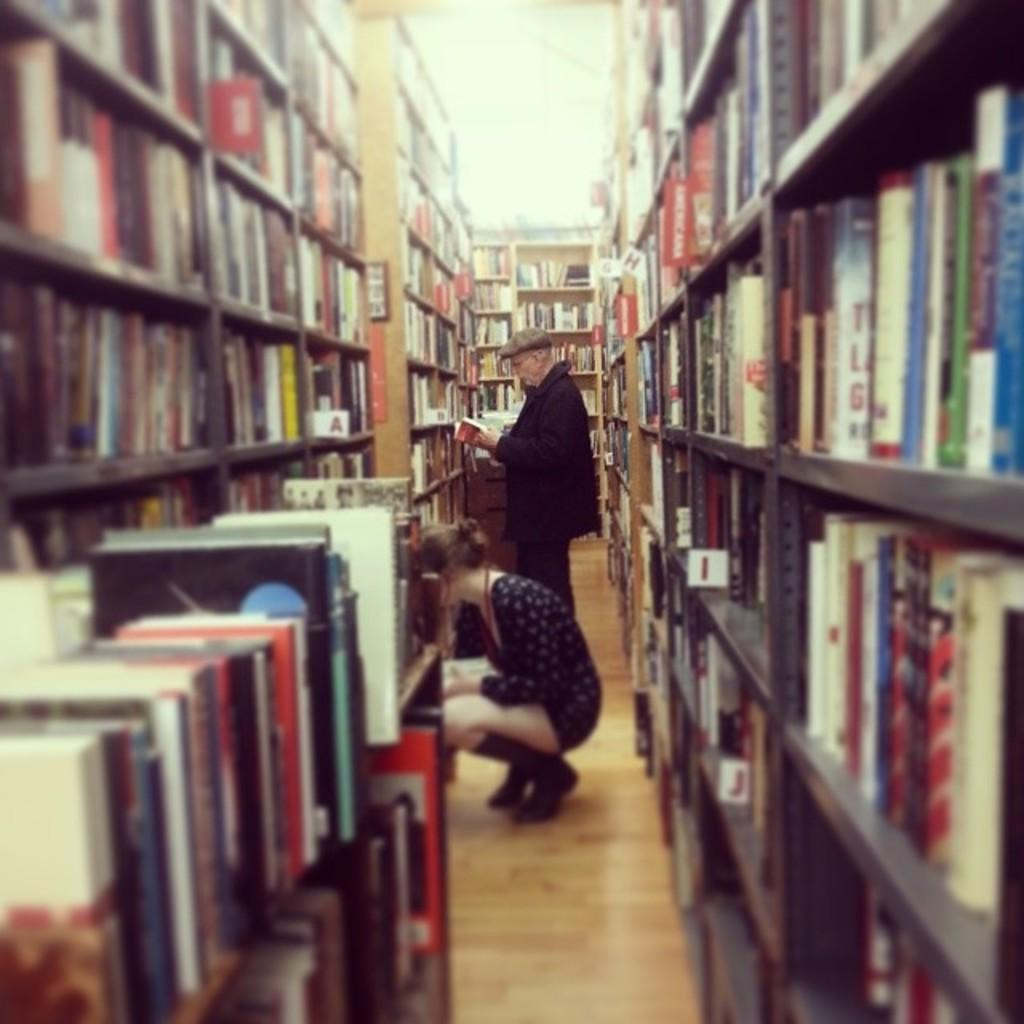<image>
Render a clear and concise summary of the photo. Two people browse in a bookstore that has letter cards that say A, H, I, and J sticking out from the shelves. 